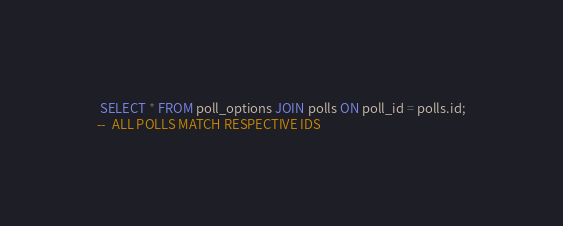<code> <loc_0><loc_0><loc_500><loc_500><_SQL_> SELECT * FROM poll_options JOIN polls ON poll_id = polls.id;
--  ALL POLLS MATCH RESPECTIVE IDS
</code> 